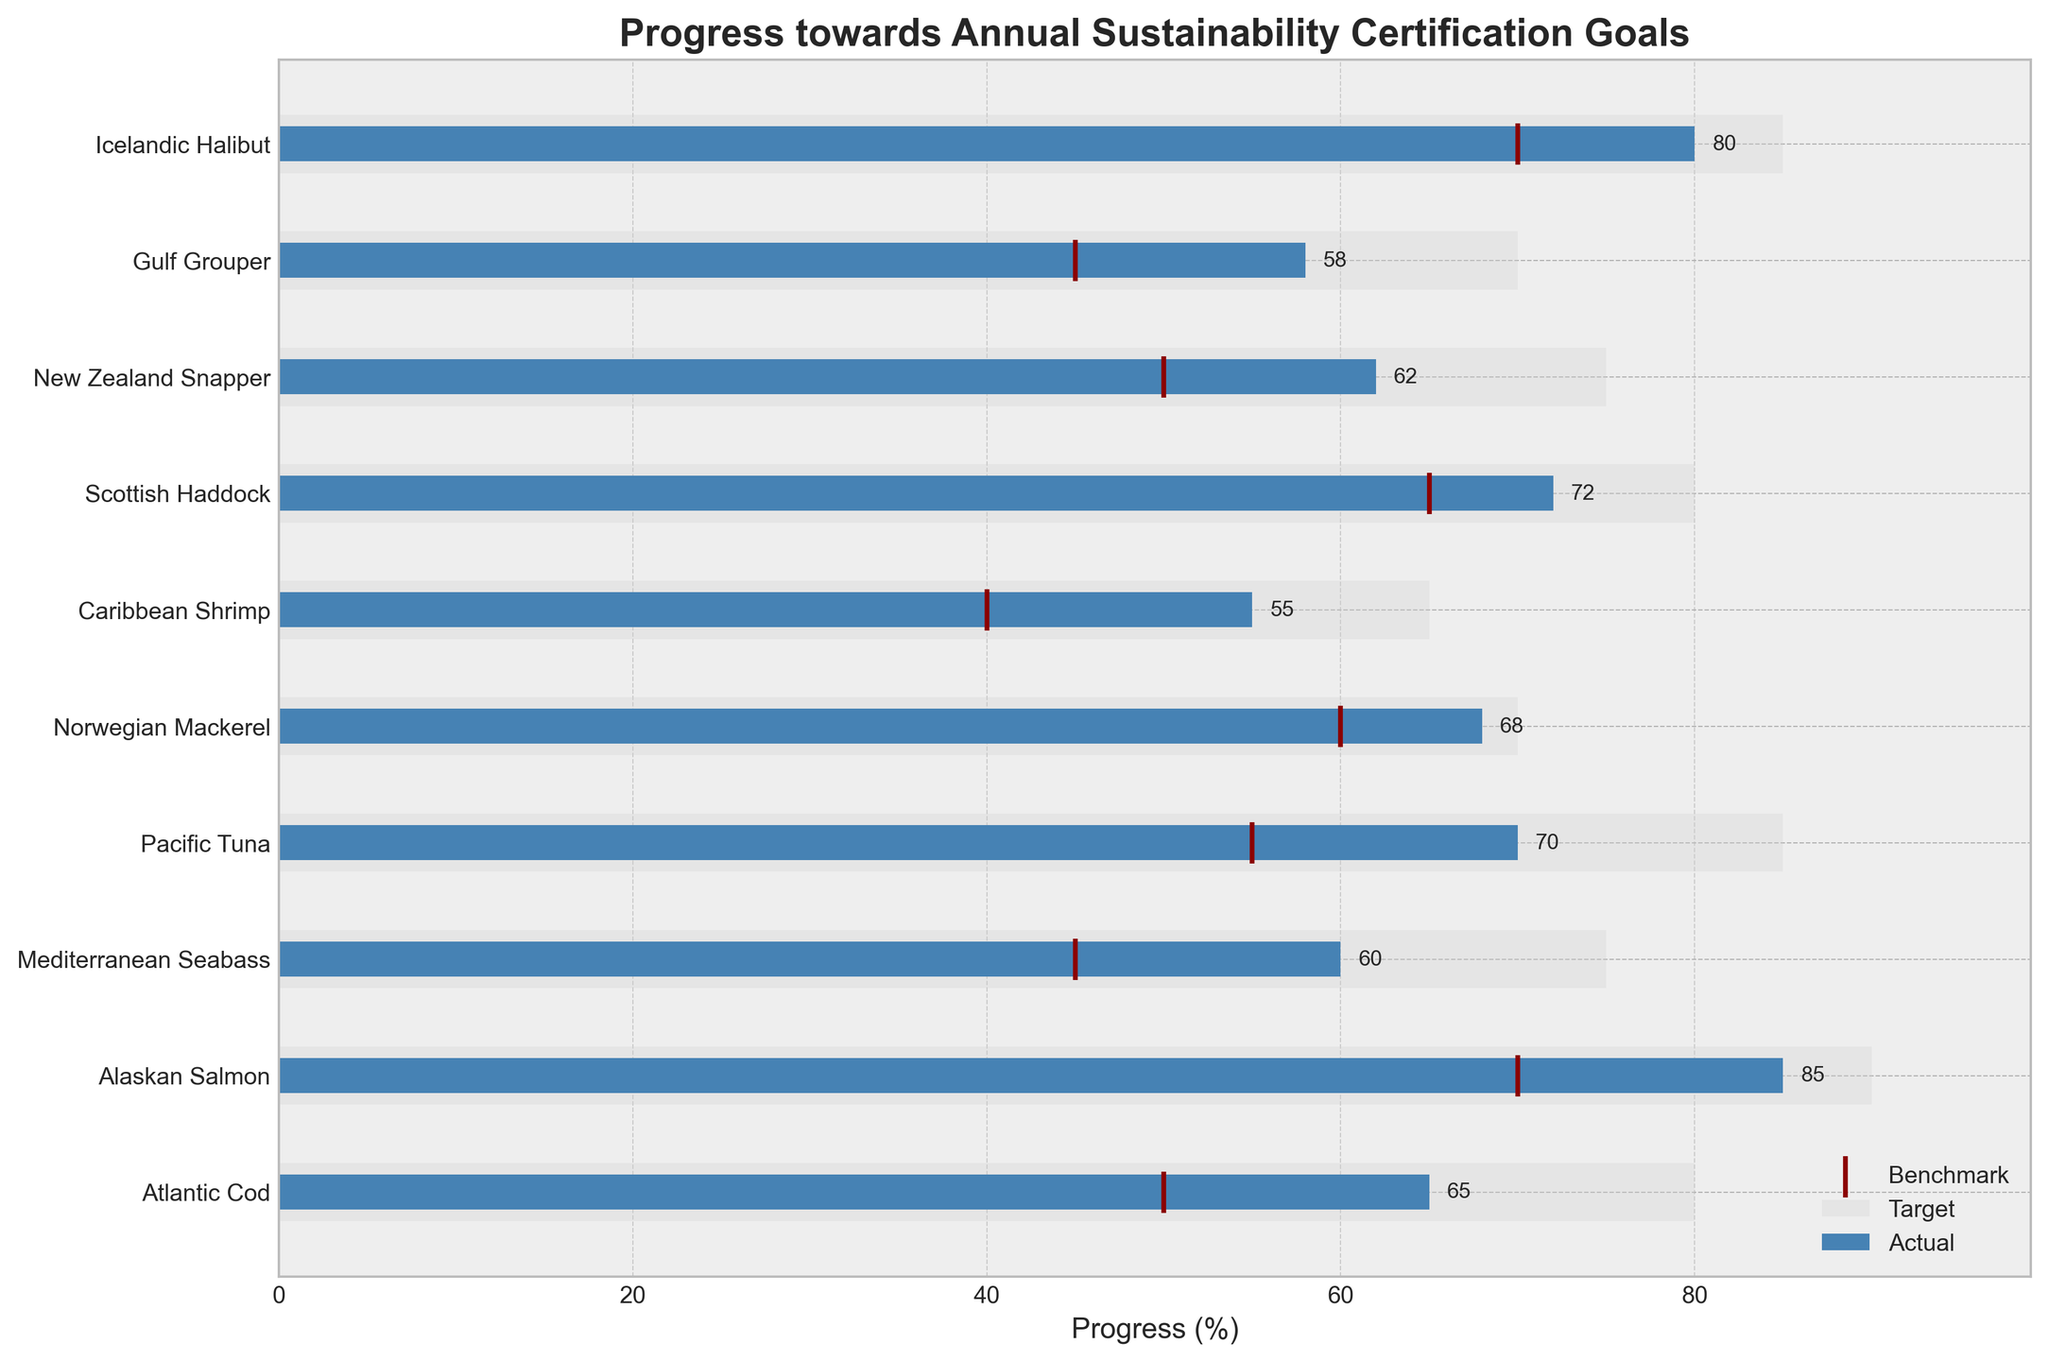What's the maximum value on the x-axis? The x-axis limit is mentioned to be set to 1.1 times the maximum target value to create a buffer. The maximum target value in the data is 90, so 1.1 times 90 gives us the maximum value on the x-axis.
Answer: 99 Which fish species has the highest target value? To find this, we look at the horizontal bars labeled "Target." The Alaskan Salmon has the highest target value of 90.
Answer: Alaskan Salmon How many fish species have their actual values marked on the chart? The y-ticks represent the species. Each species listed corresponds to one actual value. Counting them gives us 10 fish species.
Answer: 10 What's the difference between the target and actual values for Atlantic Cod? Look at the bar for Atlantic Cod. The target value is 80, and the actual value is 65. Subtracting them gives us the difference.
Answer: 15 Which fish species met or exceeded their benchmark values? We need to compare the actual values with the benchmarks for each species. Only "Alaskan Salmon" and "Icelandic Halibut" have their actual values equal to or greater than their benchmark values.
Answer: Alaskan Salmon, Icelandic Halibut Which species has the smallest gap between their actual and target values? Calculating the difference between the actual and target values for each species, we find the smallest gap for Norwegian Mackerel (70 - 68 = 2).
Answer: Norwegian Mackerel How many species have their actual values below 60% of their targets? For each species, calculate 60% of their target and compare it to their actual values. Specifically, Atlantic Cod (60% of 80 = 48), Mediterranean Seabass (60% of 75 = 45), etc. Revisit the actuals and see how many fall below their respective 60% mark. Only Mediterranean Seabass, Pacific Tuna, Caribbean Shrimp, New Zealand Snapper, and Gulf Grouper fall below.
Answer: 5 Which fish species has the highest actual value? Looking at the horizontal bars labeled "Actual," the highest actual value is 85, which corresponds to Alaskan Salmon.
Answer: Alaskan Salmon What is the median of the benchmark values given in the data? To find the median, first, list the benchmark values in ascending order: 40, 45, 45, 50, 55, 60, 65, 70, 70, 70. The median is the average of the two middle numbers in this list.
Answer: 60 What is the average target value across all species? Sum all the values in the "Target" column and divide by the number of data points. The sum is 785, and there are 10 species, so the average is 785/10.
Answer: 78.5 